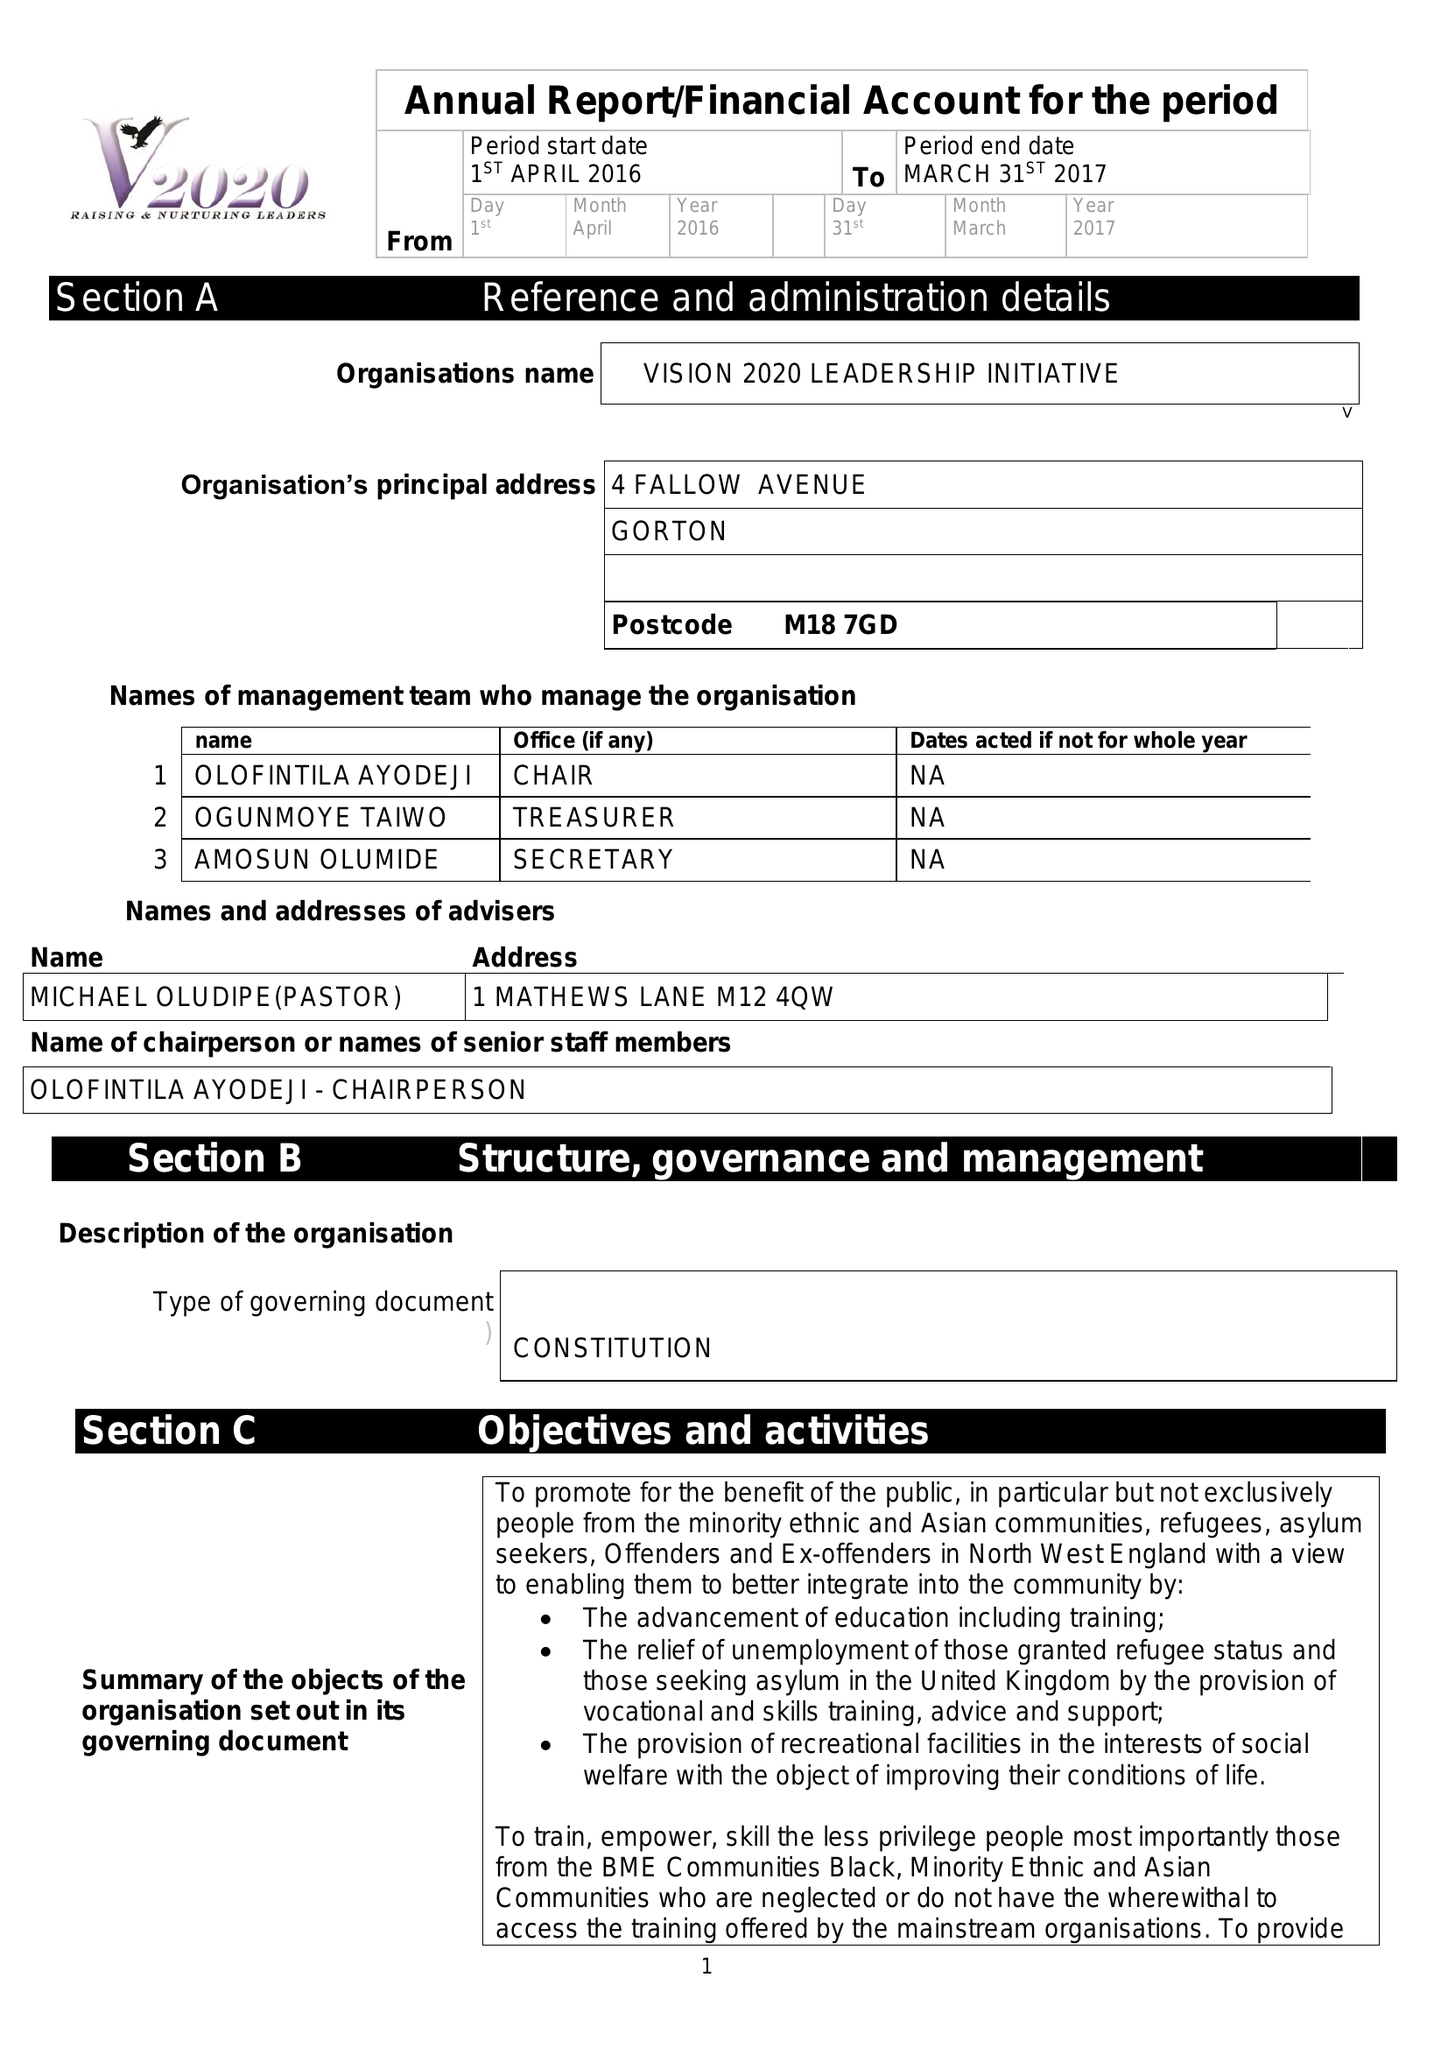What is the value for the income_annually_in_british_pounds?
Answer the question using a single word or phrase. 50135.00 